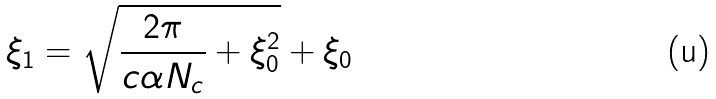Convert formula to latex. <formula><loc_0><loc_0><loc_500><loc_500>\xi _ { 1 } = { \sqrt { { \frac { 2 \pi } { c \alpha N _ { c } } } + \xi _ { 0 } ^ { 2 } } } + \xi _ { 0 }</formula> 